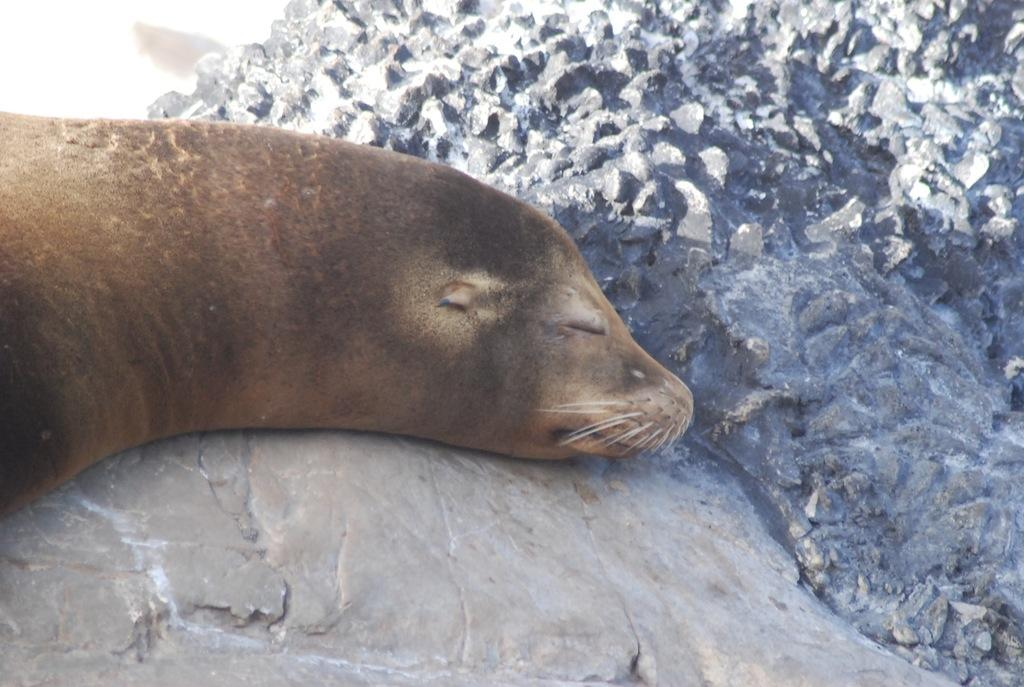What animal is featured in the image? A: There is a sea lion in the image. What is the sea lion doing in the image? The sea lion is sleeping in the image. Where is the sea lion located in the image? The sea lion is on a rock in the image. How many geese are present in the image? There are no geese present in the image; it features a sea lion sleeping on a rock. What type of debt is being discussed in the image? There is no mention of debt in the image; it only shows a sea lion sleeping on a rock. 